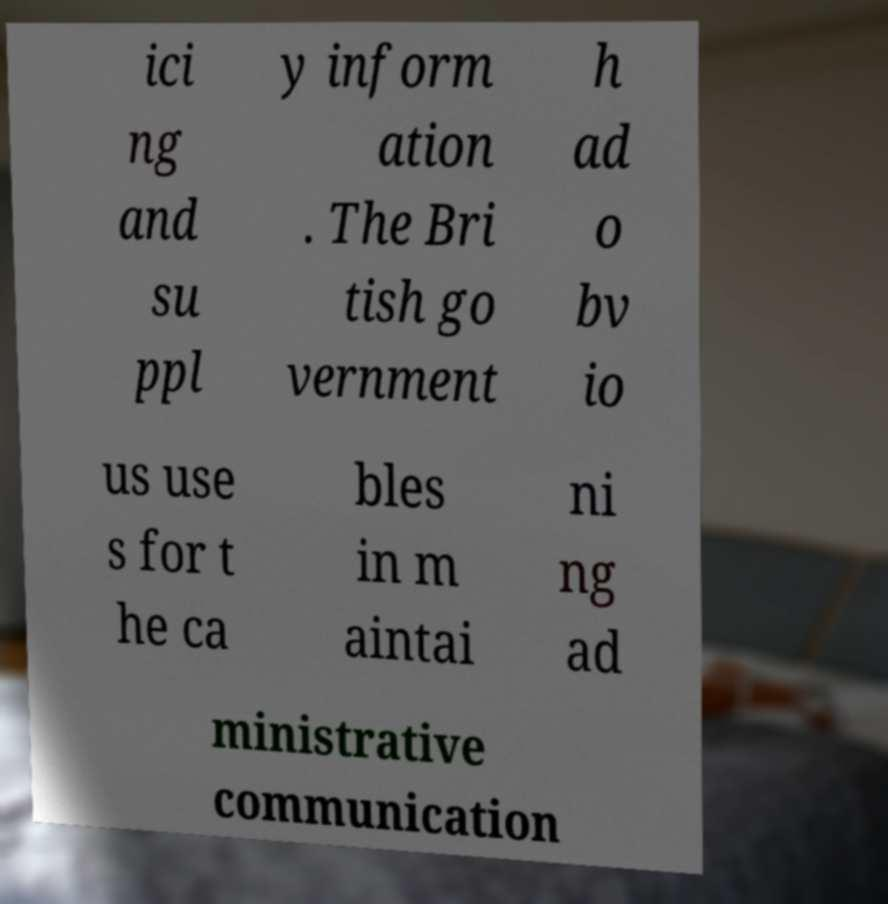Could you extract and type out the text from this image? ici ng and su ppl y inform ation . The Bri tish go vernment h ad o bv io us use s for t he ca bles in m aintai ni ng ad ministrative communication 